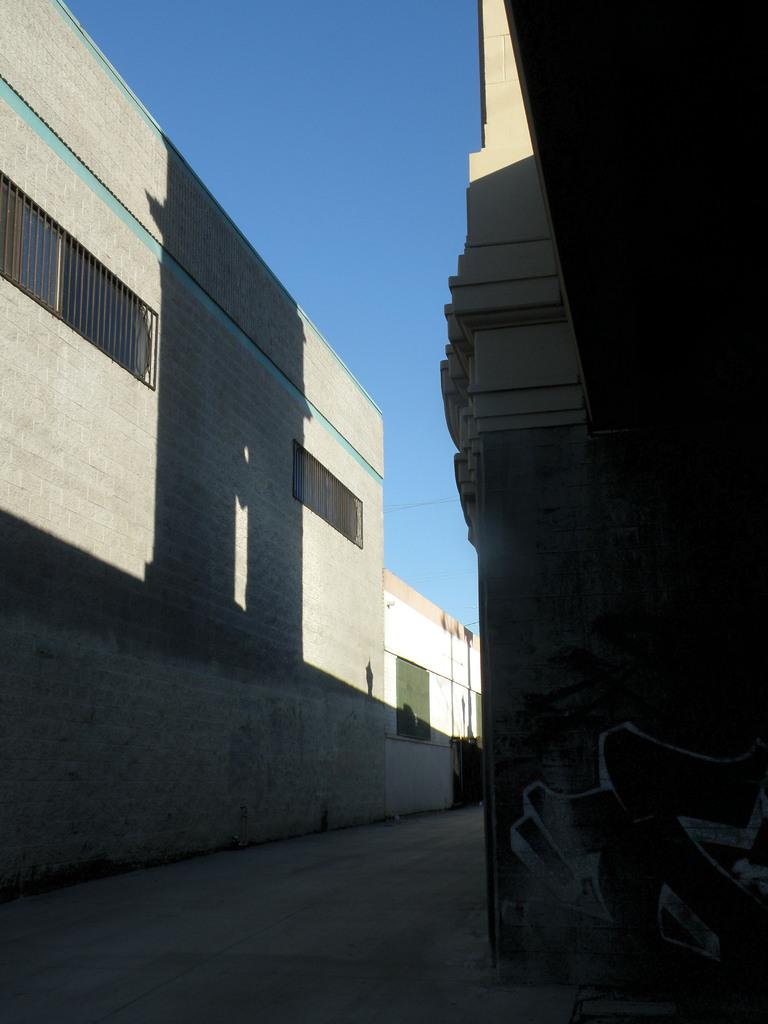What type of structures are present in the image? There are buildings in the image. What colors are the buildings? The buildings are in white and gray colors. What architectural features can be seen on the buildings? There are windows visible on the buildings. What is the color of the sky in the background of the image? The sky is blue in the background of the image. Can you see a carriage being pulled by horses in the image? No, there is no carriage or horses present in the image. Is the image depicting a winter scene? The image does not provide any information about the season, so it cannot be determined if it is a winter scene. 